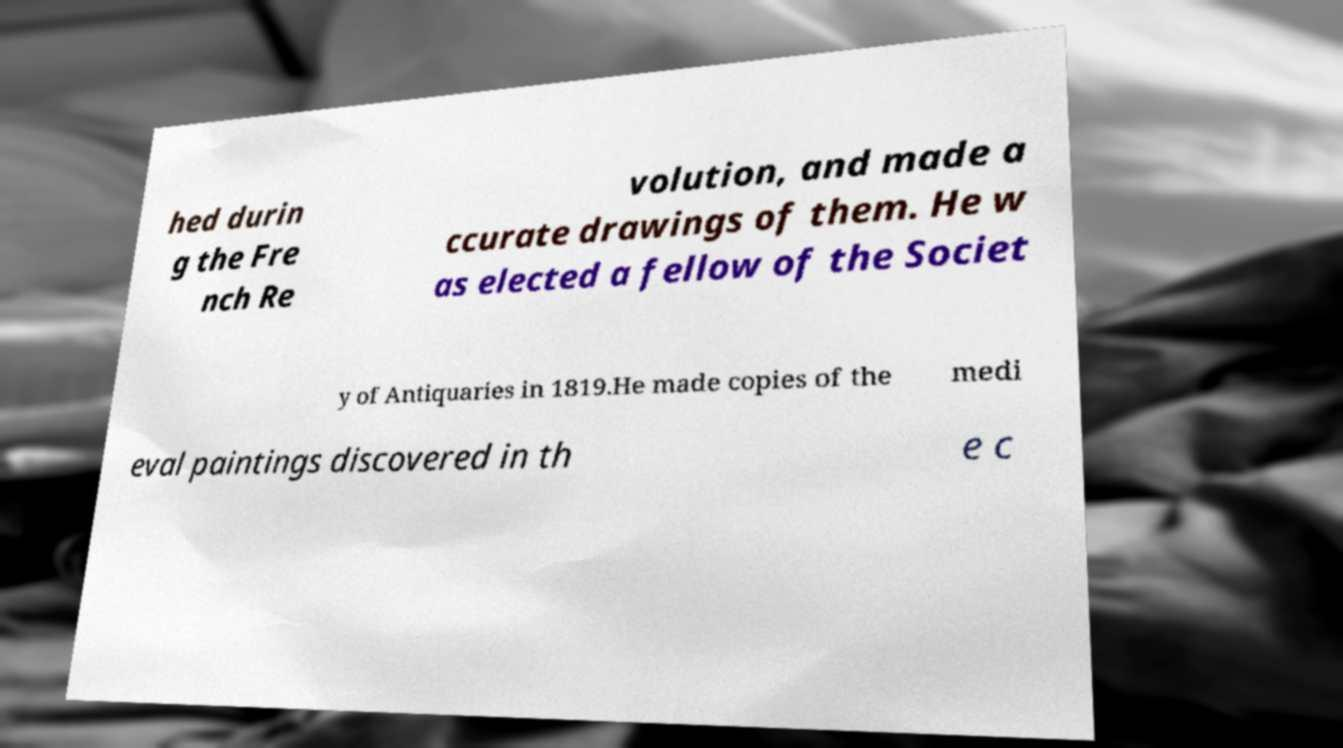Can you accurately transcribe the text from the provided image for me? hed durin g the Fre nch Re volution, and made a ccurate drawings of them. He w as elected a fellow of the Societ y of Antiquaries in 1819.He made copies of the medi eval paintings discovered in th e c 